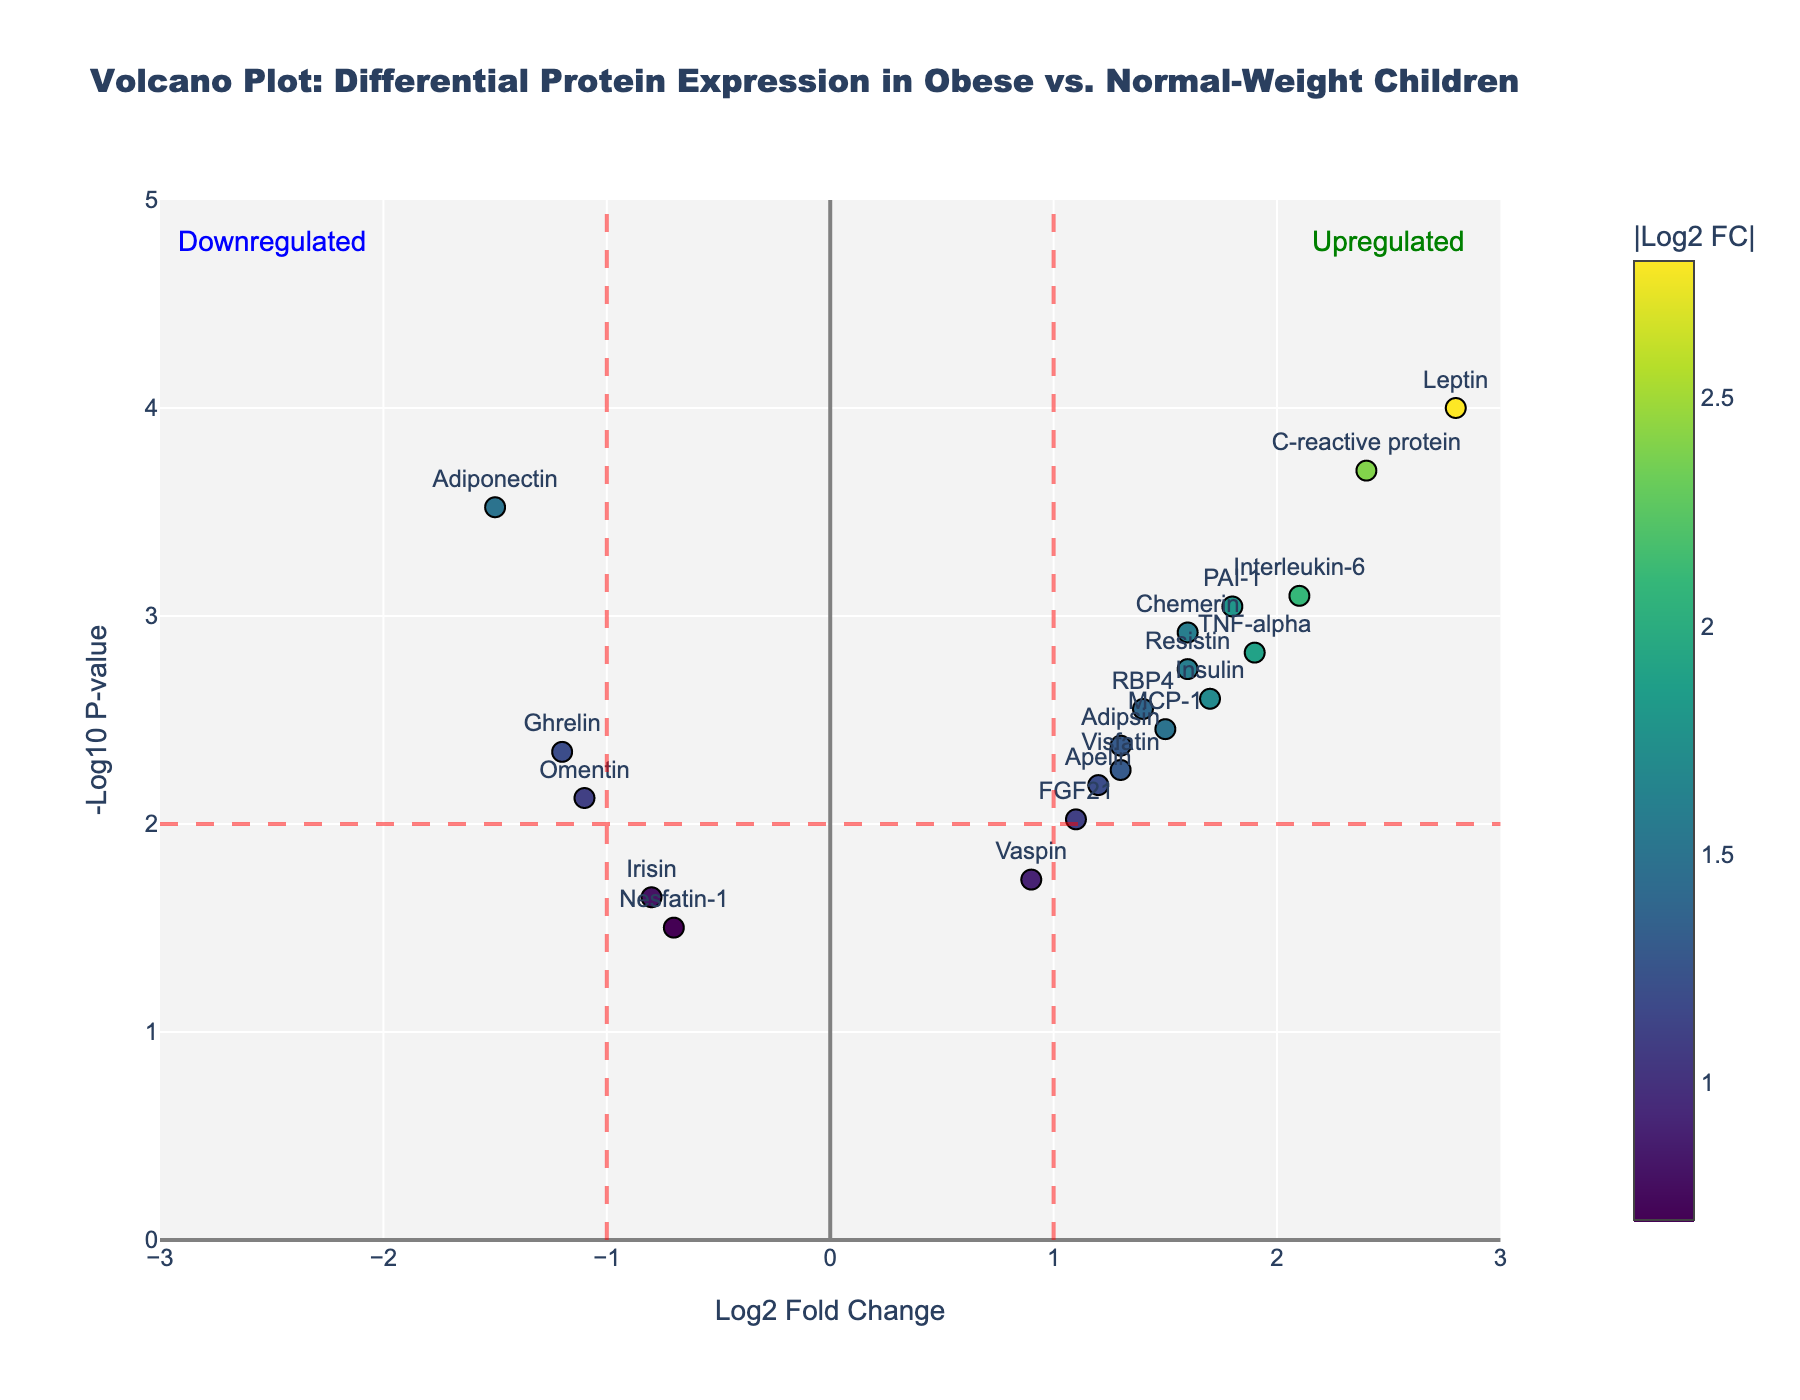How many proteins have a p-value less than 0.01? The horizontal red line represents a p-value threshold of 0.01. Proteins above this line have p-values below 0.01. By counting, we find there are 13 proteins above this line.
Answer: 13 What is the title of the plot? The title of the plot is displayed at the top of the figure. It reads "Volcano Plot: Differential Protein Expression in Obese vs. Normal-Weight Children".
Answer: Volcano Plot: Differential Protein Expression in Obese vs. Normal-Weight Children Which protein has the highest log2 fold change? By examining the x-axis values, Leptin has the highest log2 fold change at 2.8.
Answer: Leptin Which proteins are downregulated and significant? Downregulated proteins have negative log2 fold changes and those with a p-value below 0.01 are significant. By examining the left side of the plot above the significance line, Adiponectin is the downregulated and significant protein, with a log2 fold change of -1.5.
Answer: Adiponectin Compare the p-values of Leptin and Ghrelin. Which protein has a lower p-value? Leptin has a p-value of 0.0001 and Ghrelin has a p-value of 0.0045. Since 0.0001 < 0.0045, Leptin has the lower p-value.
Answer: Leptin What is the log2 fold change threshold for significance in this plot? The vertical red lines represent the log2 fold change thresholds. The x-axis of the figure shows that the thresholds are at ±1 log2 fold change.
Answer: ±1 What is the -log10 p-value for a p-value of 0.01? By definition, -log10(0.01) = 2, which is where the horizontal red line is drawn in the plot.
Answer: 2 Which protein associated with inflammation is most upregulated? Among the proteins related to inflammation, Interleukin-6 has the highest log2 fold change of 2.1.
Answer: Interleukin-6 How does the log2 fold change of Apelin compare to that of Resistin? The log2 fold change for Apelin is 1.2, whereas for Resistin it is 1.6. Since 1.6 > 1.2, Resistin has a higher log2 fold change than Apelin.
Answer: Resistin Which proteins are labeled in green, indicating they are upregulated? The figure marks proteins in the top right area with green annotation indicating upregulation. Proteins like Leptin, Interleukin-6, C-reactive protein, TNF-alpha, PAI-1, Resistin, and others in this region are labeled as upregulated.
Answer: Leptin, Interleukin-6, C-reactive protein, TNF-alpha, PAI-1, Resistin (and likely others in the upregulated section) 